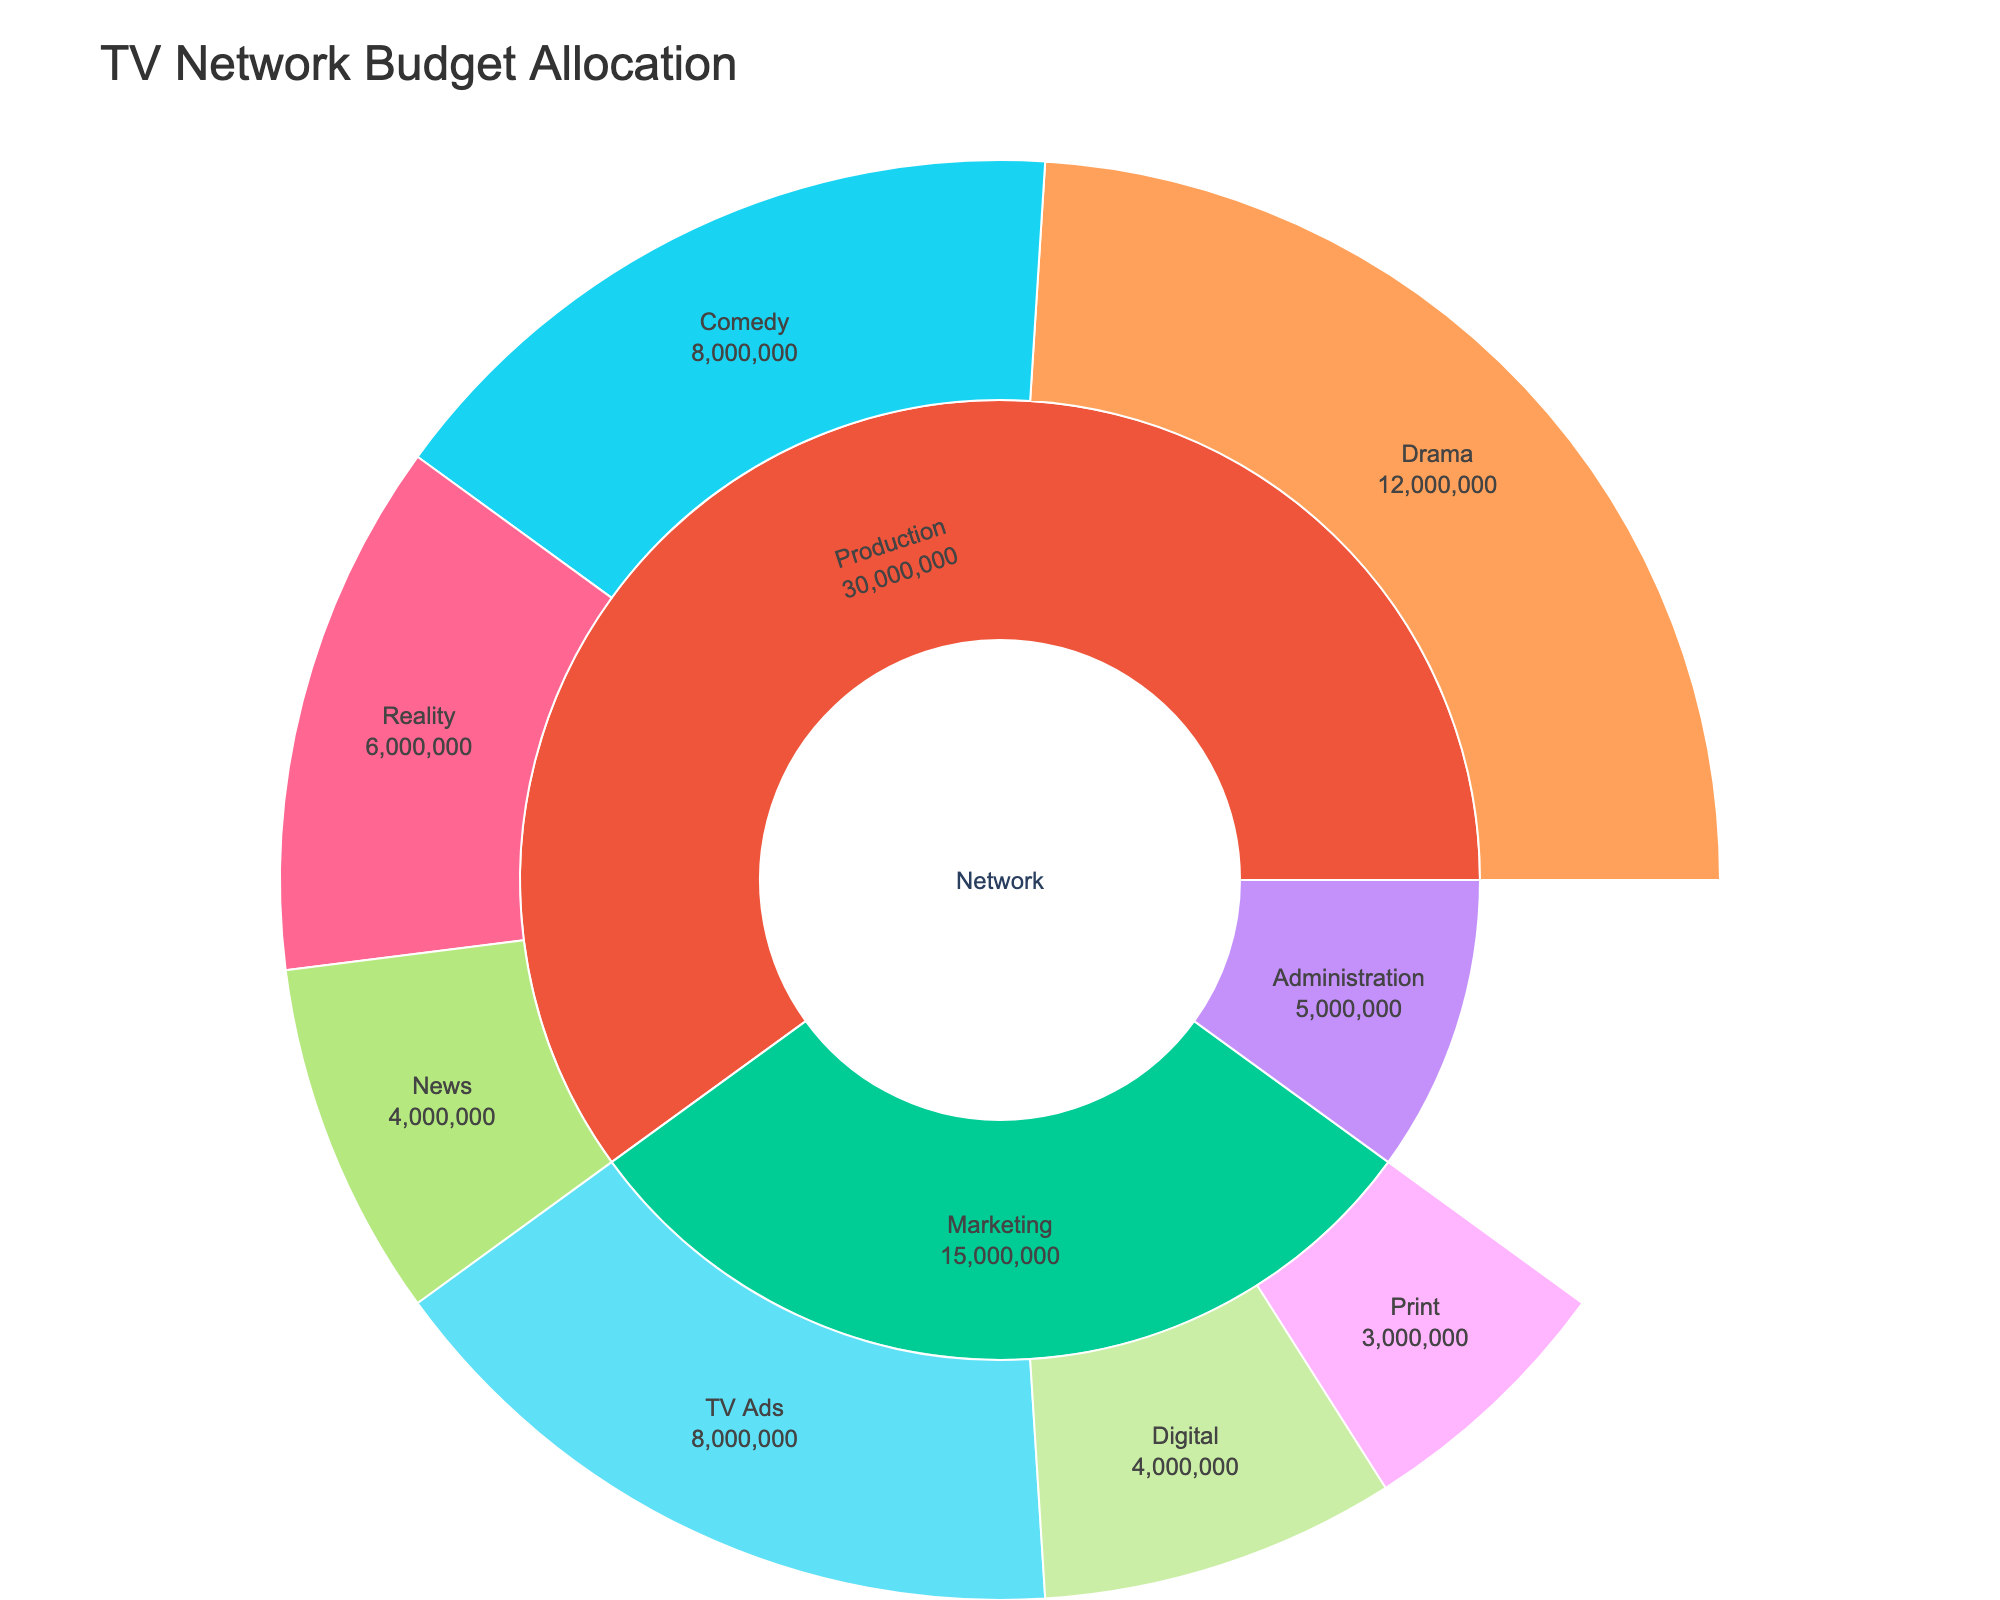What's the total budget for the TV Network? To find the total budget, look at the highest level of the hierarchy. The total budget is the sum of the Production, Marketing, and Administration departments. Sum them up: $30M + $15M + $5M.
Answer: $50M Which department within Production has the highest budget? To identify the department with the highest budget within Production, compare the values for Drama, Comedy, Reality, and News. Drama has $12M, Comedy has $8M, Reality has $6M, and News has $4M. Therefore, Drama has the highest budget.
Answer: Drama How much is allocated to Talent across all departments in Production? To find the total budget for Talent, sum the amounts for Talent in Drama, Comedy, and Reality departments. Talent in Drama is $5M, in Comedy is $3.5M, and in Reality is $2M. Sum these values: $5M + $3.5M + $2M.
Answer: $10.5M Which has a higher budget: Marketing or the Drama department in Production? Compare the total budget for Marketing and the Drama department in Production. Marketing has $15M, and Drama has $12M.
Answer: Marketing What's the combined budget for Sets in Drama and Comedy? To find the combined budget, sum the budget for Sets in Drama and Sets in Comedy. Sets in Drama is $4M and Sets in Comedy is $2.5M. Sum these values: $4M + $2.5M.
Answer: $6.5M What percentage of the total Production budget is allocated to News? First, find the total Production budget, which is $30M. The News budget is $4M. To find the percentage, divide the News budget by the total Production budget and multiply by 100. ($4M / $30M) * 100.
Answer: 13.33% Which is higher: the budget for Digital marketing or for Crew in all Production departments combined? Compare the budget for Digital marketing ($4M) with the sum of the Crew budget in all Production departments. Crew in Drama is $3M, in Comedy is $2M, in Reality is $1.5M, and in News is $1M. Sum these: $3M + $2M + $1.5M + $1M.
Answer: Digital What is the total budget for Administration and the News department? Sum the budget for Administration and News. Administration has $5M and News has $4M. Sum these values: $5M + $4M.
Answer: $9M How does the budget for TV Ads compare to the budget for Sets in the Drama department? Compare the budget for TV Ads ($8M) to the budget for Sets in the Drama department ($4M).
Answer: TV Ads 